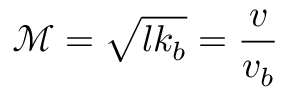<formula> <loc_0><loc_0><loc_500><loc_500>\mathcal { M } = \sqrt { l k _ { b } } = \frac { v } { v _ { b } }</formula> 